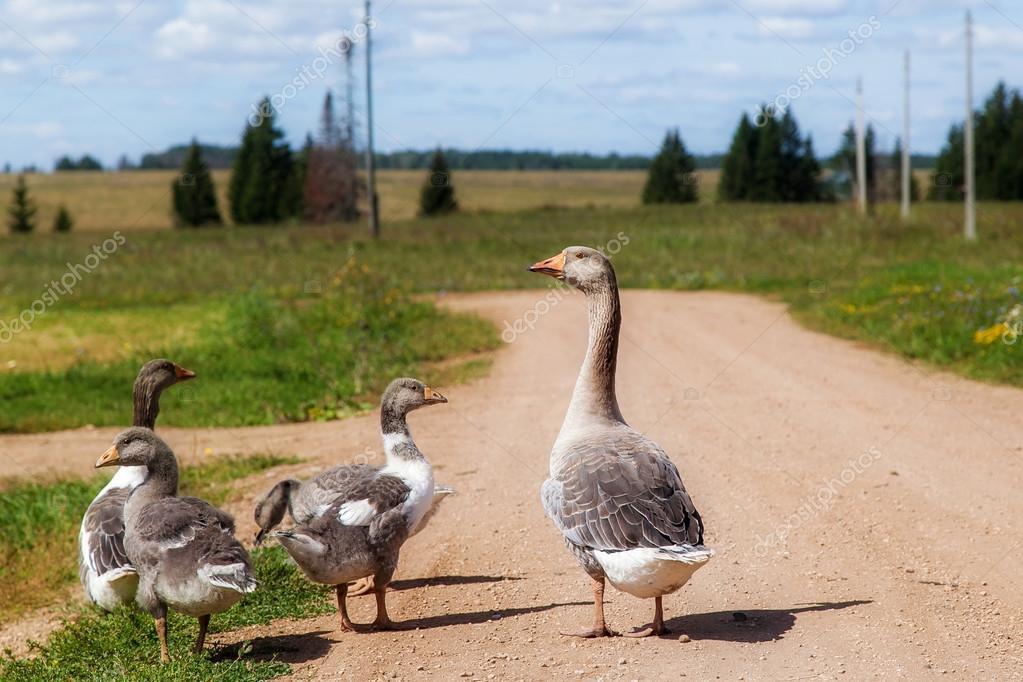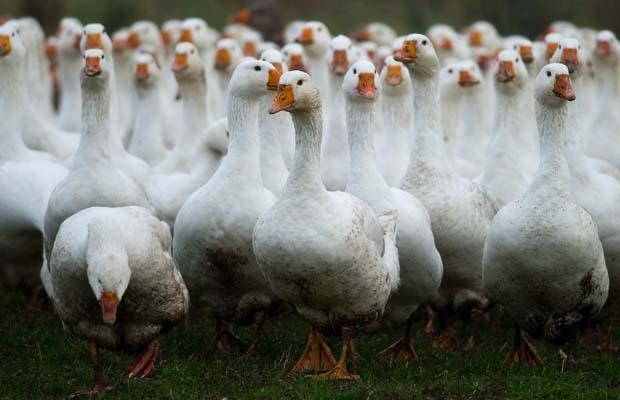The first image is the image on the left, the second image is the image on the right. Assess this claim about the two images: "One image features multiple ducks on a country road, and the other image shows a mass of white ducks that are not in flight.". Correct or not? Answer yes or no. Yes. 